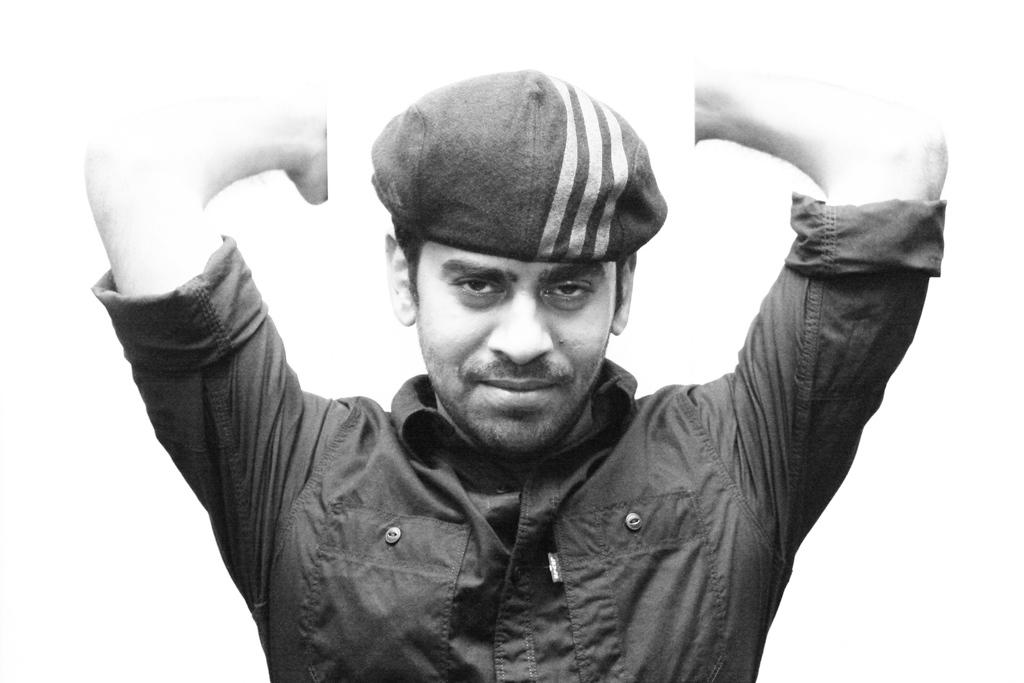What is the color scheme of the picture? The picture is black and white. Who is in the picture? There is a man in the picture. What is the man wearing on his head? The man is wearing a cap. What color is the background of the picture? The background of the picture is white. Can you tell me how many drawers are visible in the picture? There are no drawers present in the picture; it features a man wearing a cap against a white background. What type of animal is standing next to the man in the picture? There is no animal, such as a zebra, present in the picture; it only features a man wearing a cap against a white background. 